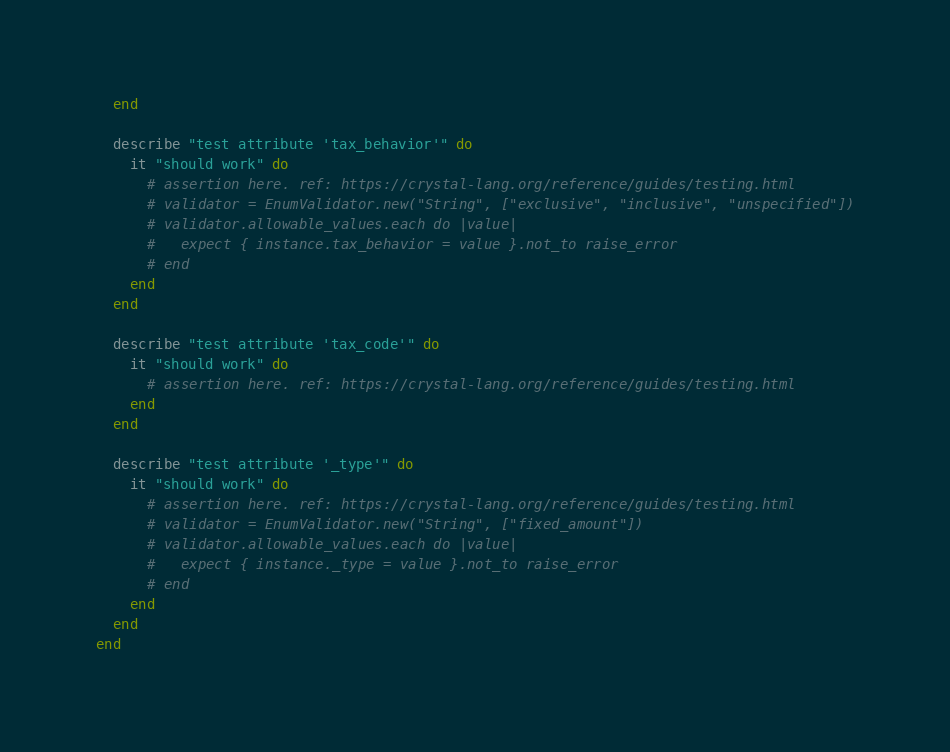<code> <loc_0><loc_0><loc_500><loc_500><_Crystal_>  end

  describe "test attribute 'tax_behavior'" do
    it "should work" do
      # assertion here. ref: https://crystal-lang.org/reference/guides/testing.html
      # validator = EnumValidator.new("String", ["exclusive", "inclusive", "unspecified"])
      # validator.allowable_values.each do |value|
      #   expect { instance.tax_behavior = value }.not_to raise_error
      # end
    end
  end

  describe "test attribute 'tax_code'" do
    it "should work" do
      # assertion here. ref: https://crystal-lang.org/reference/guides/testing.html
    end
  end

  describe "test attribute '_type'" do
    it "should work" do
      # assertion here. ref: https://crystal-lang.org/reference/guides/testing.html
      # validator = EnumValidator.new("String", ["fixed_amount"])
      # validator.allowable_values.each do |value|
      #   expect { instance._type = value }.not_to raise_error
      # end
    end
  end
end
</code> 